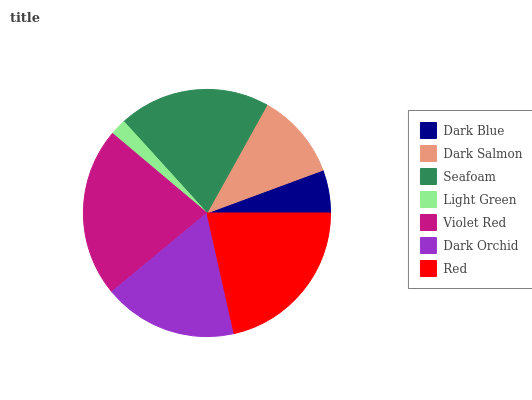Is Light Green the minimum?
Answer yes or no. Yes. Is Violet Red the maximum?
Answer yes or no. Yes. Is Dark Salmon the minimum?
Answer yes or no. No. Is Dark Salmon the maximum?
Answer yes or no. No. Is Dark Salmon greater than Dark Blue?
Answer yes or no. Yes. Is Dark Blue less than Dark Salmon?
Answer yes or no. Yes. Is Dark Blue greater than Dark Salmon?
Answer yes or no. No. Is Dark Salmon less than Dark Blue?
Answer yes or no. No. Is Dark Orchid the high median?
Answer yes or no. Yes. Is Dark Orchid the low median?
Answer yes or no. Yes. Is Red the high median?
Answer yes or no. No. Is Seafoam the low median?
Answer yes or no. No. 